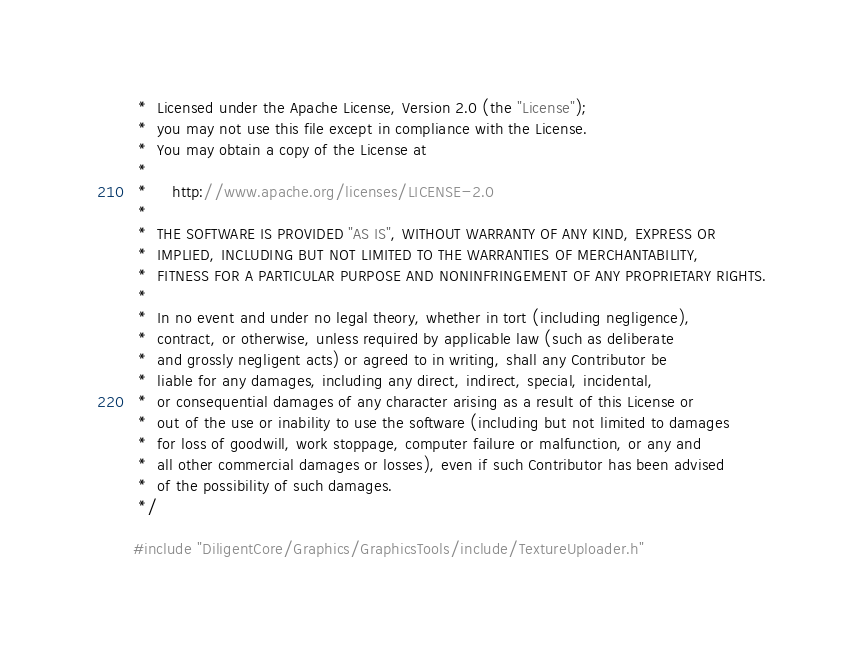<code> <loc_0><loc_0><loc_500><loc_500><_C++_> *  Licensed under the Apache License, Version 2.0 (the "License");
 *  you may not use this file except in compliance with the License.
 *  You may obtain a copy of the License at
 * 
 *     http://www.apache.org/licenses/LICENSE-2.0
 * 
 *  THE SOFTWARE IS PROVIDED "AS IS", WITHOUT WARRANTY OF ANY KIND, EXPRESS OR
 *  IMPLIED, INCLUDING BUT NOT LIMITED TO THE WARRANTIES OF MERCHANTABILITY,
 *  FITNESS FOR A PARTICULAR PURPOSE AND NONINFRINGEMENT OF ANY PROPRIETARY RIGHTS.
 *
 *  In no event and under no legal theory, whether in tort (including negligence), 
 *  contract, or otherwise, unless required by applicable law (such as deliberate 
 *  and grossly negligent acts) or agreed to in writing, shall any Contributor be
 *  liable for any damages, including any direct, indirect, special, incidental, 
 *  or consequential damages of any character arising as a result of this License or 
 *  out of the use or inability to use the software (including but not limited to damages 
 *  for loss of goodwill, work stoppage, computer failure or malfunction, or any and 
 *  all other commercial damages or losses), even if such Contributor has been advised 
 *  of the possibility of such damages.
 */

#include "DiligentCore/Graphics/GraphicsTools/include/TextureUploader.h"
</code> 